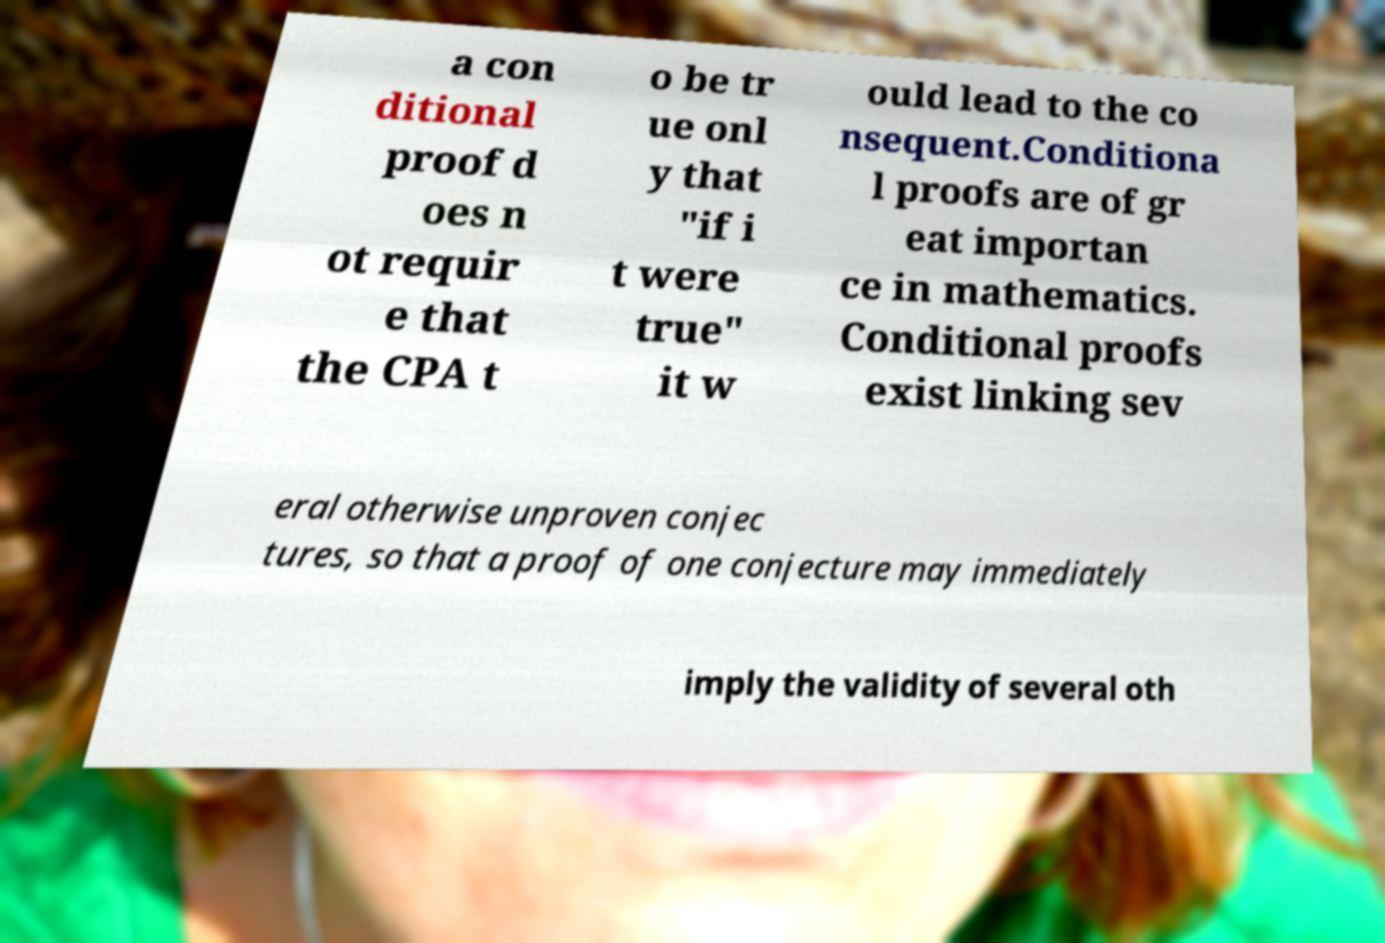Please identify and transcribe the text found in this image. a con ditional proof d oes n ot requir e that the CPA t o be tr ue onl y that "if i t were true" it w ould lead to the co nsequent.Conditiona l proofs are of gr eat importan ce in mathematics. Conditional proofs exist linking sev eral otherwise unproven conjec tures, so that a proof of one conjecture may immediately imply the validity of several oth 